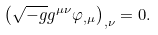Convert formula to latex. <formula><loc_0><loc_0><loc_500><loc_500>\left ( \sqrt { - g } g ^ { \mu \nu } \varphi _ { , \mu } \right ) _ { , \nu } = 0 .</formula> 